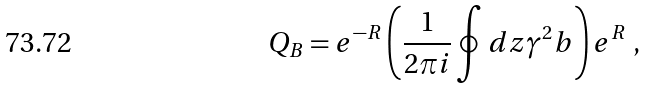<formula> <loc_0><loc_0><loc_500><loc_500>Q _ { B } = e ^ { - R } \left ( \frac { 1 } { 2 \pi i } \oint d z \gamma ^ { 2 } b \right ) e ^ { R } \ ,</formula> 